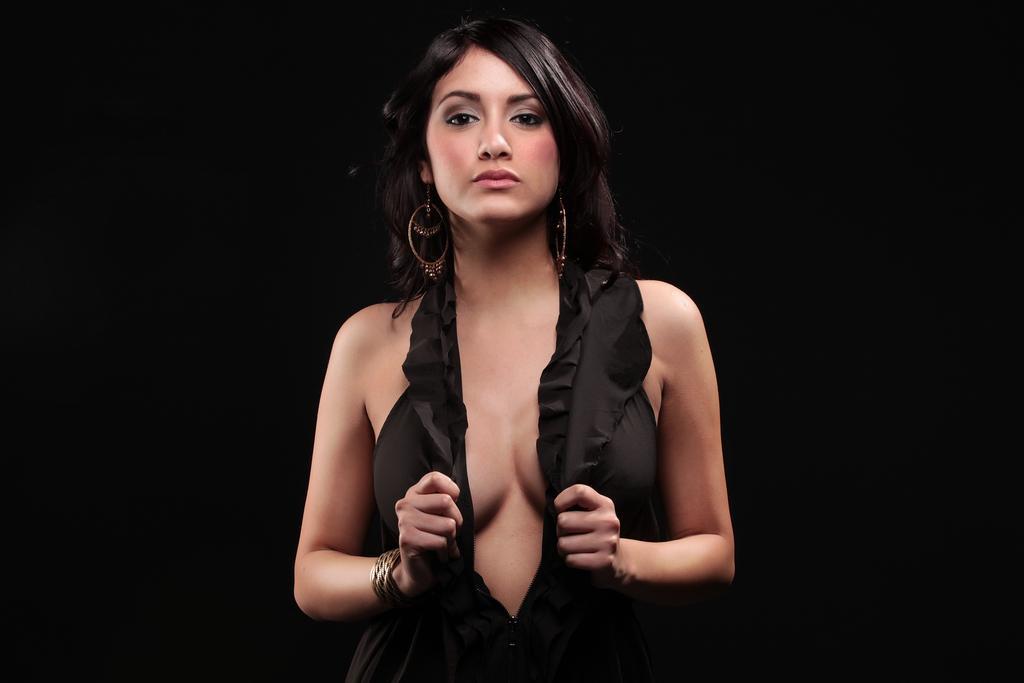Could you give a brief overview of what you see in this image? In this image we can see a woman wearing a black dress and posing for a photo. The background image is in dark color. 